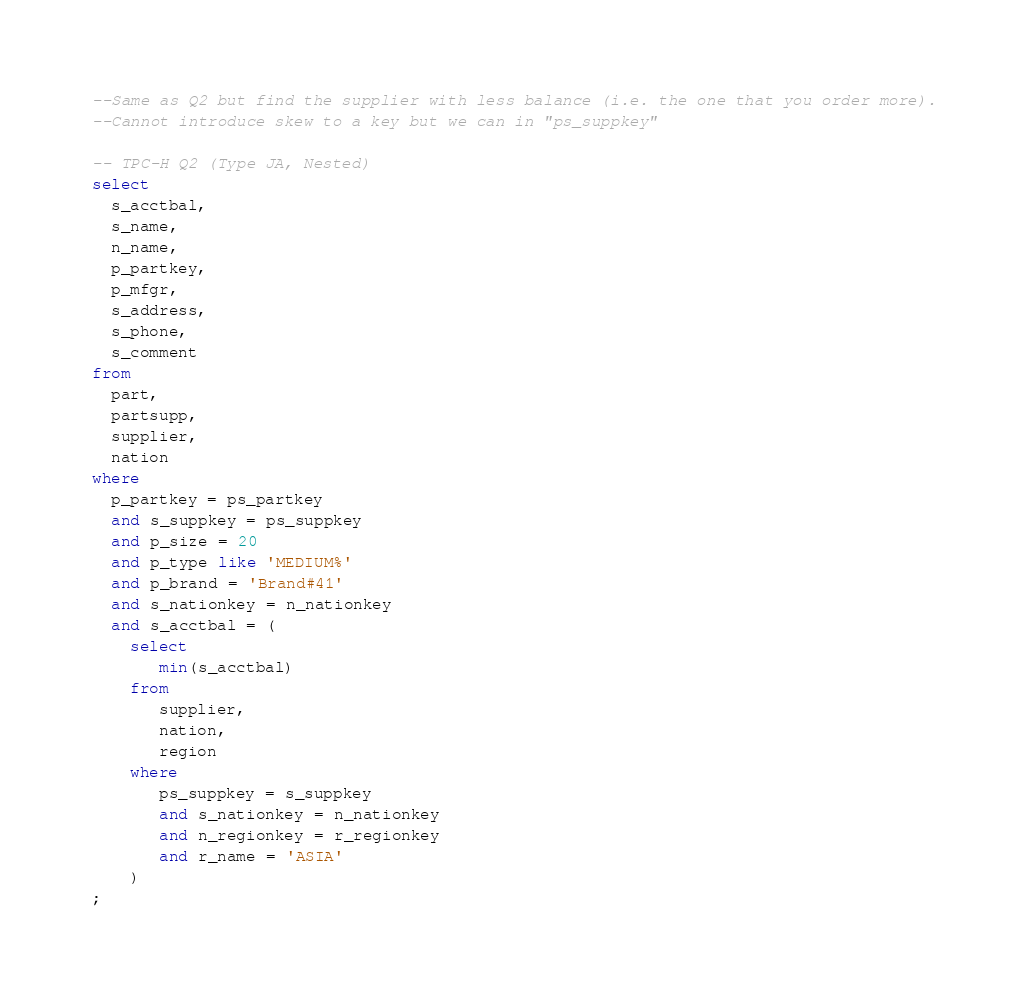<code> <loc_0><loc_0><loc_500><loc_500><_SQL_>--Same as Q2 but find the supplier with less balance (i.e. the one that you order more).
--Cannot introduce skew to a key but we can in "ps_suppkey"

-- TPC-H Q2 (Type JA, Nested)
select
  s_acctbal,
  s_name,
  n_name,
  p_partkey,
  p_mfgr,
  s_address,
  s_phone,
  s_comment
from
  part,
  partsupp,
  supplier,
  nation
where
  p_partkey = ps_partkey
  and s_suppkey = ps_suppkey
  and p_size = 20
  and p_type like 'MEDIUM%'
  and p_brand = 'Brand#41'
  and s_nationkey = n_nationkey
  and s_acctbal = (
    select
       min(s_acctbal)
    from
       supplier,
       nation, 
       region
    where
       ps_suppkey = s_suppkey
       and s_nationkey = n_nationkey
       and n_regionkey = r_regionkey
       and r_name = 'ASIA'
    )
;
</code> 